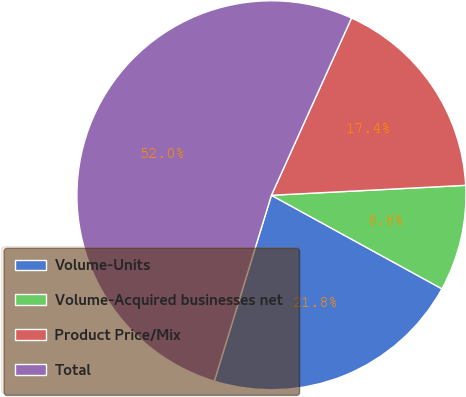<chart> <loc_0><loc_0><loc_500><loc_500><pie_chart><fcel>Volume-Units<fcel>Volume-Acquired businesses net<fcel>Product Price/Mix<fcel>Total<nl><fcel>21.76%<fcel>8.8%<fcel>17.43%<fcel>52.01%<nl></chart> 